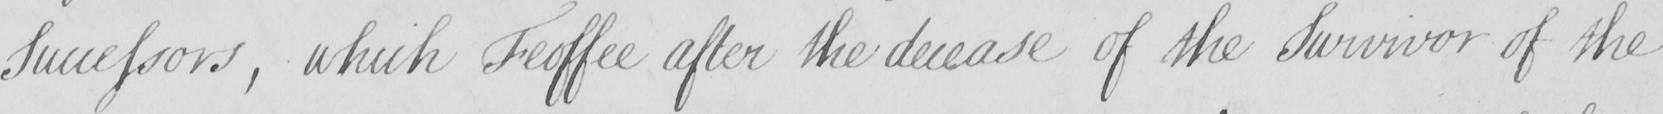Can you tell me what this handwritten text says? Successors , which Feoffee after the decease of the Survivor of the 